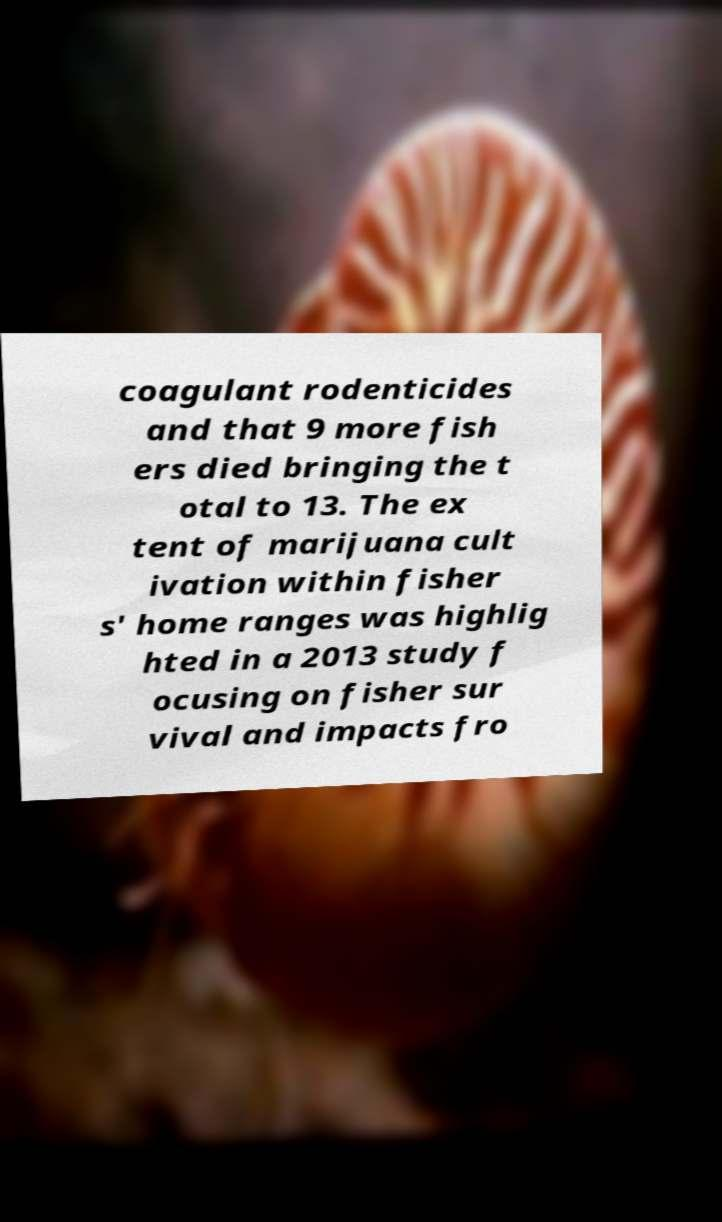I need the written content from this picture converted into text. Can you do that? coagulant rodenticides and that 9 more fish ers died bringing the t otal to 13. The ex tent of marijuana cult ivation within fisher s' home ranges was highlig hted in a 2013 study f ocusing on fisher sur vival and impacts fro 